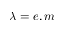<formula> <loc_0><loc_0><loc_500><loc_500>\lambda = e , m</formula> 